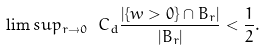Convert formula to latex. <formula><loc_0><loc_0><loc_500><loc_500>\lim s u p _ { r \to 0 } \ C _ { d } \frac { | \{ w > 0 \} \cap B _ { r } | } { | B _ { r } | } < \frac { 1 } { 2 } .</formula> 